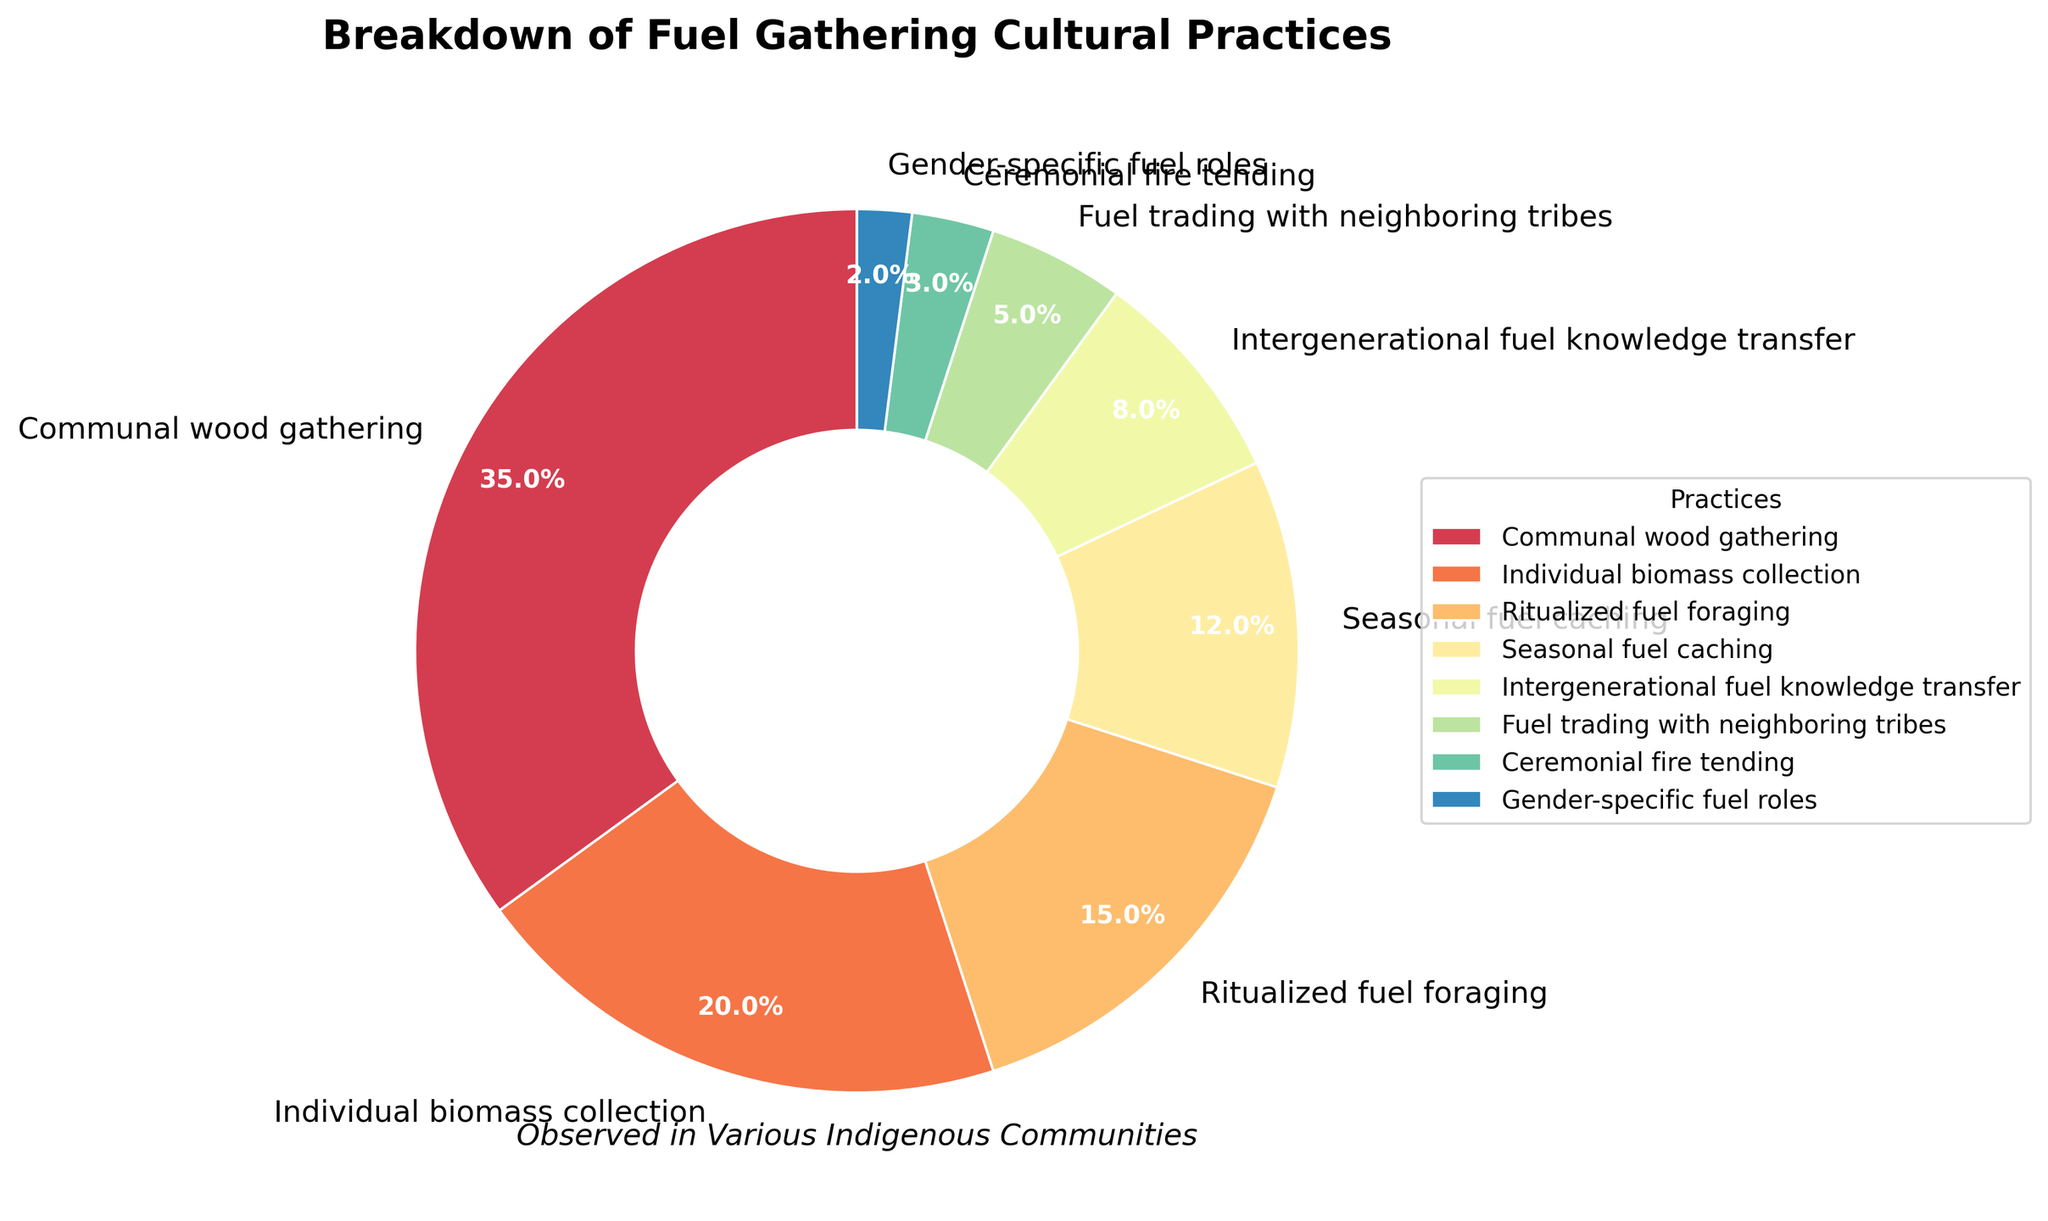Which practice has the highest percentage? The practice with the highest percentage is the one with the largest segment in the pie chart. This is typically what stands out the most in terms of size.
Answer: Communal wood gathering What is the combined percentage of Ritualized fuel foraging and Seasonal fuel caching? Sum the percentages of both practices: Ritualized fuel foraging (15%) and Seasonal fuel caching (12%). Therefore, 15% + 12% = 27%.
Answer: 27% Which practice lies between Individual biomass collection and Intergenerational fuel knowledge transfer in terms of percentage? Look at the order of the practices based on their percentages. Individual biomass collection is 20%, and Intergenerational fuel knowledge transfer is 8%, the practice between these two is Seasonal fuel caching which is 12%.
Answer: Seasonal fuel caching Is the percentage of Communal wood gathering greater than the combined percentage of Fuel trading with neighboring tribes and Ceremonial fire tending? Compare the percentage of Communal wood gathering (35%) with the sum of Fuel trading with neighboring tribes (5%) and Ceremonial fire tending (3%): 5% + 3% = 8%. Yes, 35% is greater than 8%.
Answer: Yes What is the difference in percentage between Ritualized fuel foraging and Gender-specific fuel roles? Subtract the percentage of Gender-specific fuel roles (2%) from Ritualized fuel foraging (15%): 15% - 2% = 13%.
Answer: 13% How many practices make up less than 10% of the total? Identify the practices that are less than 10%: Intergenerational fuel knowledge transfer (8%), Fuel trading with neighboring tribes (5%), Ceremonial fire tending (3%), and Gender-specific fuel roles (2%). Count these practices.
Answer: 4 What percentage do the practices related to Seasonal fuel caching and Gender-specific fuel roles constitute together? Sum the percentages of Seasonal fuel caching (12%) and Gender-specific fuel roles (2%): 12% + 2% = 14%.
Answer: 14% Which color represents the practice of Intergenerational fuel knowledge transfer? Identify the segment labeled as "Intergenerational fuel knowledge transfer" and note its color. Since this question requires visual identification from the pie chart, we'll assume it has a unique color easily distinguishable from others.
Answer: (Color identified in the chart) 